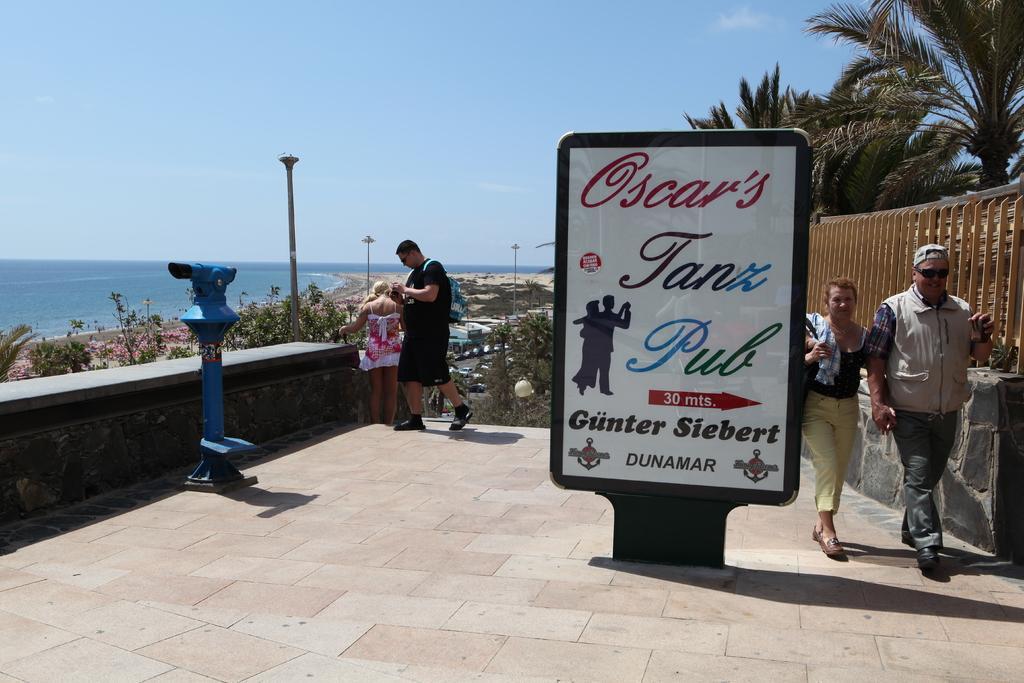Please provide a concise description of this image. On the right corner of the picture, we see the man and woman are walking. Beside them, we see a white board with some text written on it. Beside that, we see an iron railing. In the middle of the picture, we see the man and the girl are standing. There are many trees and street lights in the background. On the left corner of the picture, we see a blue color pole water and at the top of the picture, we see the sky. 